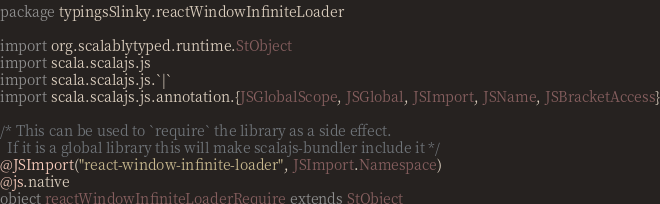<code> <loc_0><loc_0><loc_500><loc_500><_Scala_>package typingsSlinky.reactWindowInfiniteLoader

import org.scalablytyped.runtime.StObject
import scala.scalajs.js
import scala.scalajs.js.`|`
import scala.scalajs.js.annotation.{JSGlobalScope, JSGlobal, JSImport, JSName, JSBracketAccess}

/* This can be used to `require` the library as a side effect.
  If it is a global library this will make scalajs-bundler include it */
@JSImport("react-window-infinite-loader", JSImport.Namespace)
@js.native
object reactWindowInfiniteLoaderRequire extends StObject
</code> 